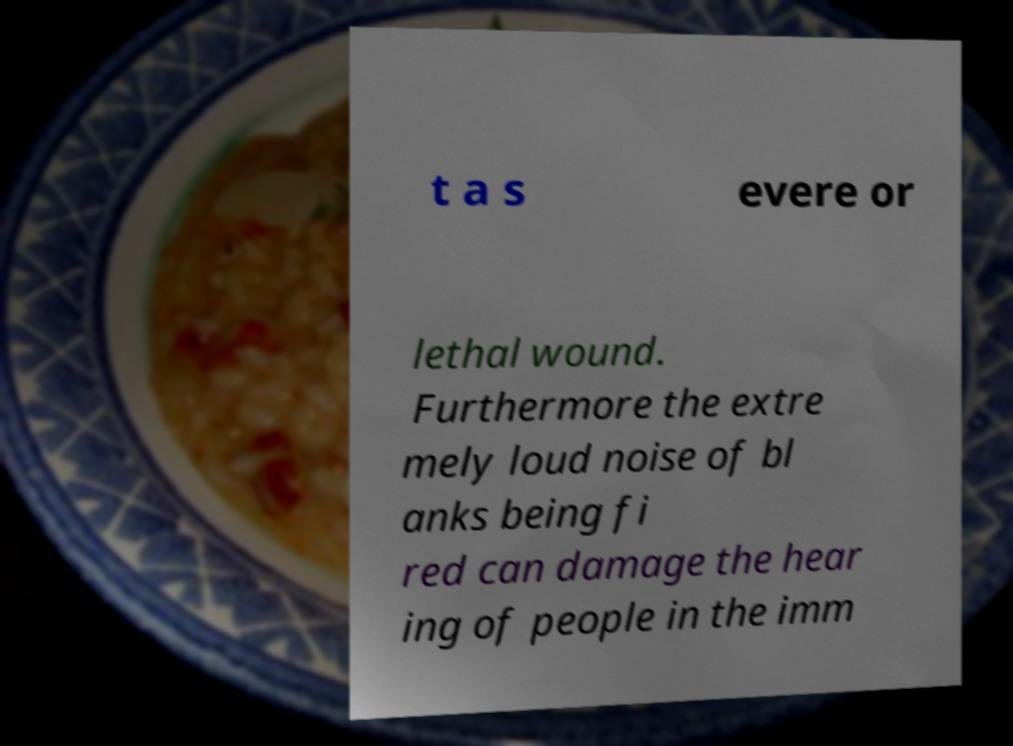For documentation purposes, I need the text within this image transcribed. Could you provide that? t a s evere or lethal wound. Furthermore the extre mely loud noise of bl anks being fi red can damage the hear ing of people in the imm 